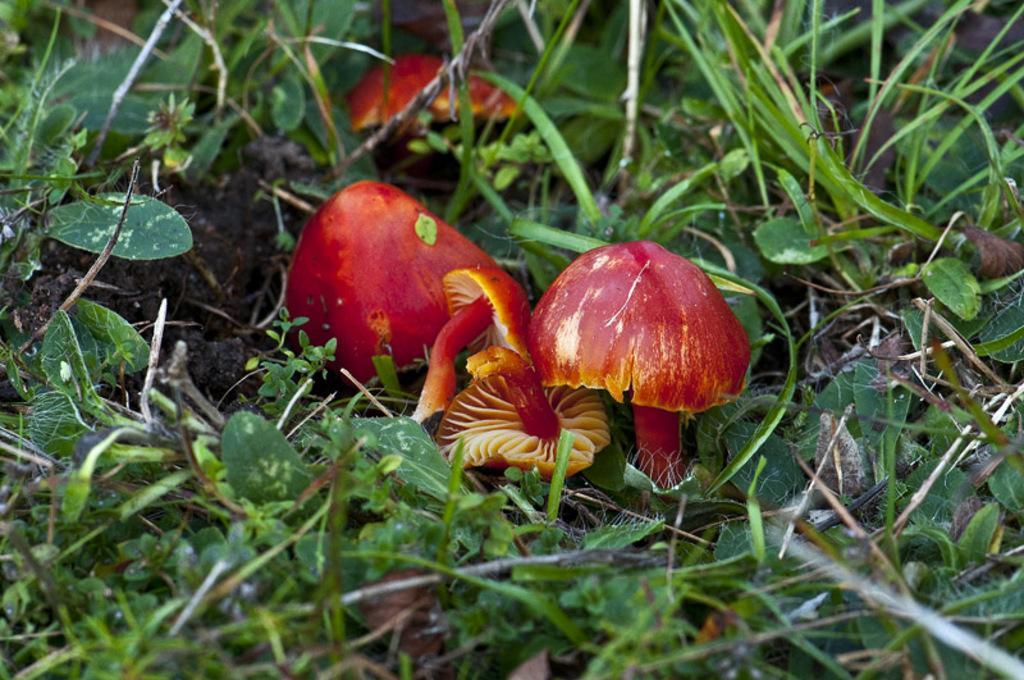Could you give a brief overview of what you see in this image? In this image on the ground there are mushrooms, grasses and plants are there. 